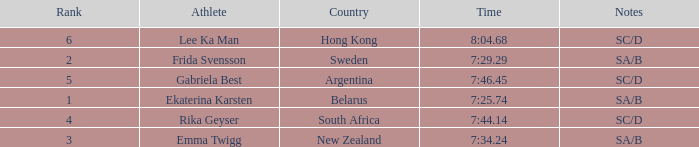What is the race time for emma twigg? 7:34.24. 